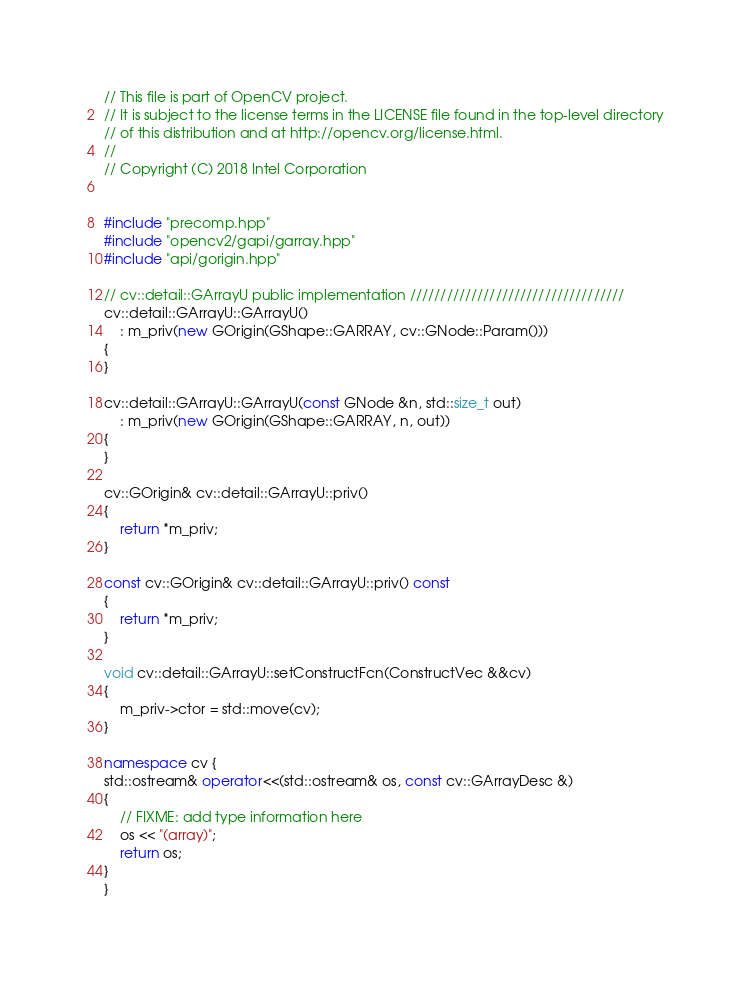<code> <loc_0><loc_0><loc_500><loc_500><_C++_>// This file is part of OpenCV project.
// It is subject to the license terms in the LICENSE file found in the top-level directory
// of this distribution and at http://opencv.org/license.html.
//
// Copyright (C) 2018 Intel Corporation


#include "precomp.hpp"
#include "opencv2/gapi/garray.hpp"
#include "api/gorigin.hpp"

// cv::detail::GArrayU public implementation ///////////////////////////////////
cv::detail::GArrayU::GArrayU()
    : m_priv(new GOrigin(GShape::GARRAY, cv::GNode::Param()))
{
}

cv::detail::GArrayU::GArrayU(const GNode &n, std::size_t out)
    : m_priv(new GOrigin(GShape::GARRAY, n, out))
{
}

cv::GOrigin& cv::detail::GArrayU::priv()
{
    return *m_priv;
}

const cv::GOrigin& cv::detail::GArrayU::priv() const
{
    return *m_priv;
}

void cv::detail::GArrayU::setConstructFcn(ConstructVec &&cv)
{
    m_priv->ctor = std::move(cv);
}

namespace cv {
std::ostream& operator<<(std::ostream& os, const cv::GArrayDesc &)
{
    // FIXME: add type information here
    os << "(array)";
    return os;
}
}
</code> 